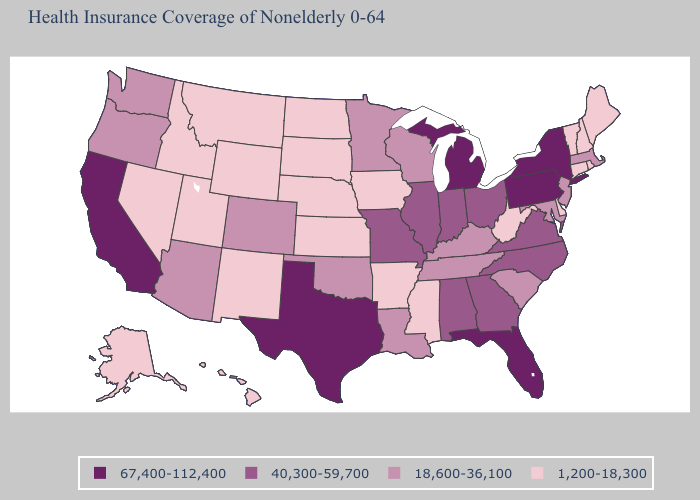Does Delaware have the highest value in the South?
Give a very brief answer. No. What is the lowest value in the USA?
Keep it brief. 1,200-18,300. What is the value of Georgia?
Give a very brief answer. 40,300-59,700. What is the value of Alabama?
Give a very brief answer. 40,300-59,700. Name the states that have a value in the range 67,400-112,400?
Keep it brief. California, Florida, Michigan, New York, Pennsylvania, Texas. What is the value of Iowa?
Be succinct. 1,200-18,300. Does Connecticut have a lower value than West Virginia?
Write a very short answer. No. Name the states that have a value in the range 1,200-18,300?
Concise answer only. Alaska, Arkansas, Connecticut, Delaware, Hawaii, Idaho, Iowa, Kansas, Maine, Mississippi, Montana, Nebraska, Nevada, New Hampshire, New Mexico, North Dakota, Rhode Island, South Dakota, Utah, Vermont, West Virginia, Wyoming. Which states have the lowest value in the South?
Write a very short answer. Arkansas, Delaware, Mississippi, West Virginia. How many symbols are there in the legend?
Write a very short answer. 4. Does Delaware have the lowest value in the USA?
Short answer required. Yes. Does Colorado have the lowest value in the USA?
Be succinct. No. Among the states that border Maine , which have the lowest value?
Answer briefly. New Hampshire. What is the value of Alaska?
Short answer required. 1,200-18,300. 